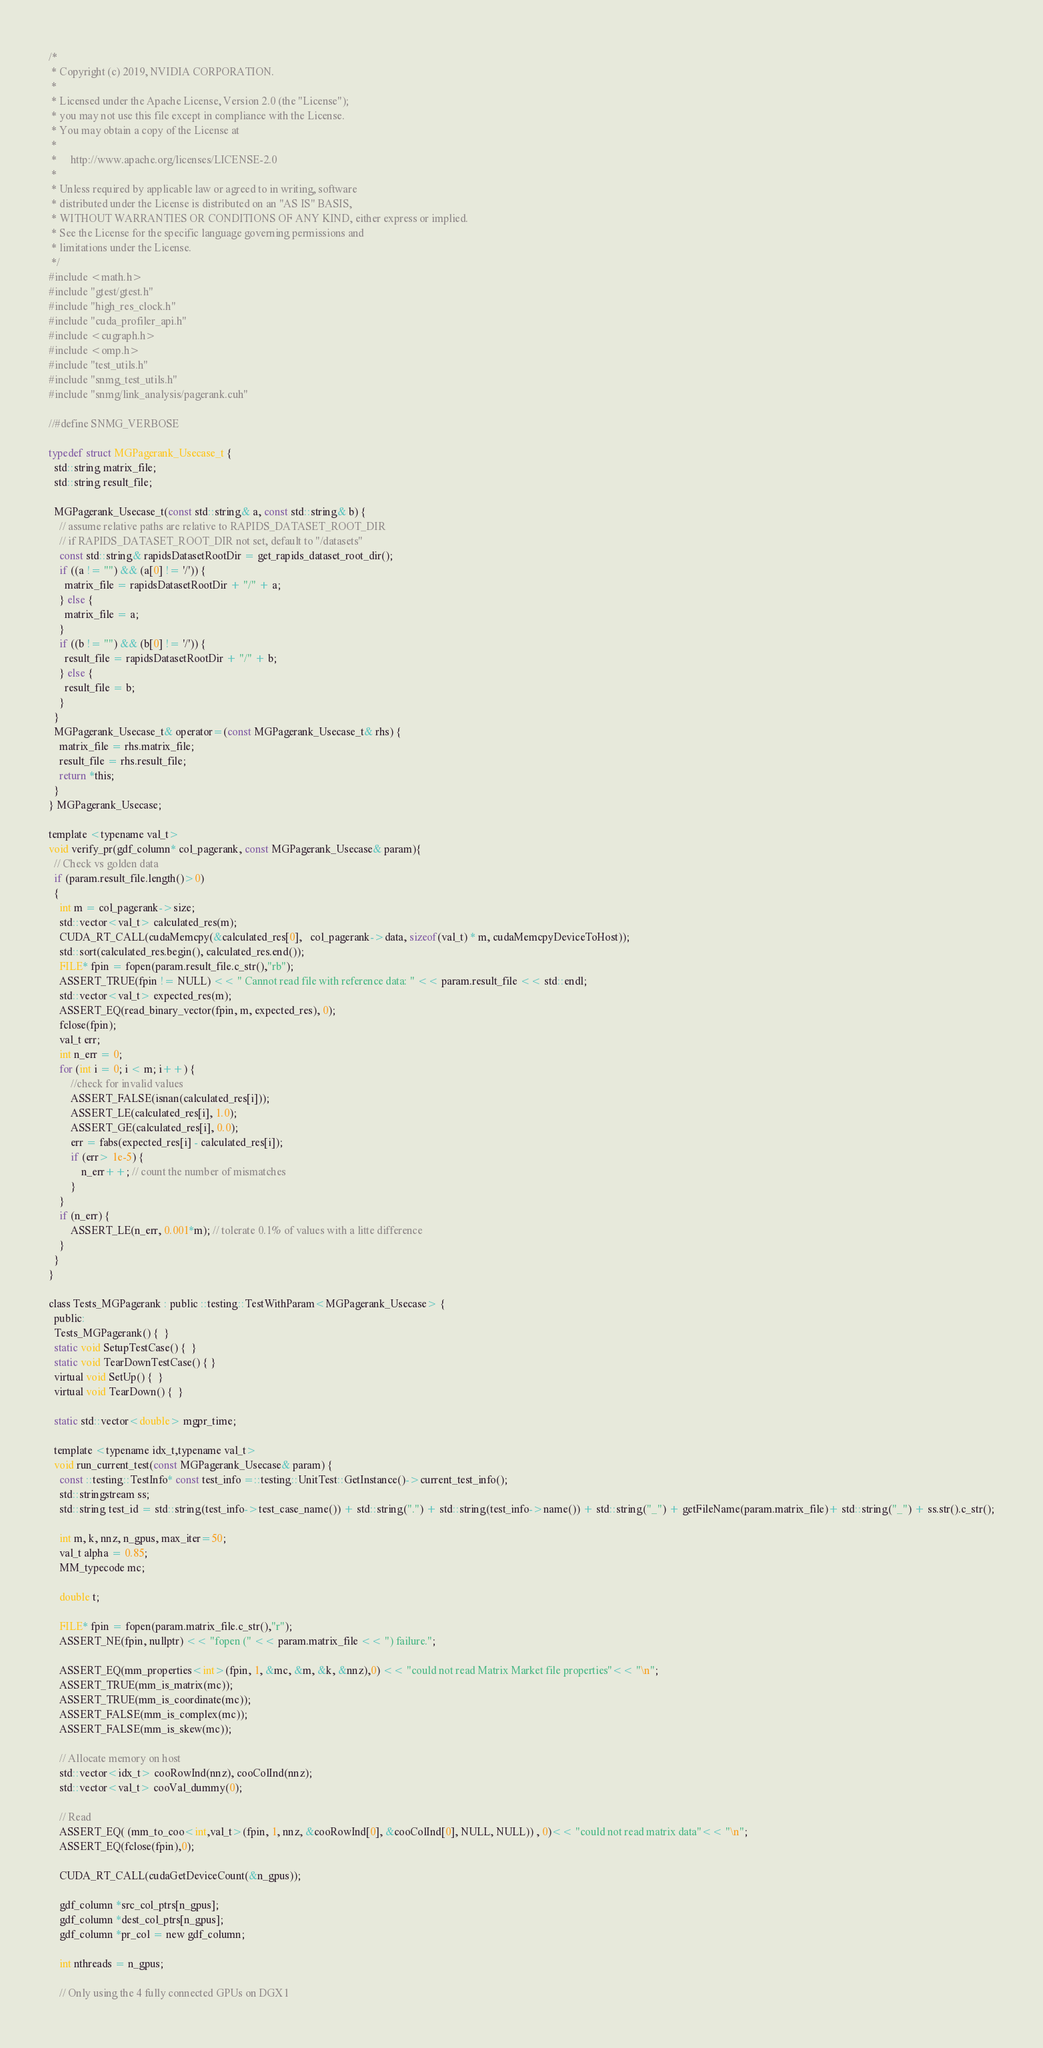<code> <loc_0><loc_0><loc_500><loc_500><_Cuda_>/*
 * Copyright (c) 2019, NVIDIA CORPORATION.
 *
 * Licensed under the Apache License, Version 2.0 (the "License");
 * you may not use this file except in compliance with the License.
 * You may obtain a copy of the License at
 *
 *     http://www.apache.org/licenses/LICENSE-2.0
 *
 * Unless required by applicable law or agreed to in writing, software
 * distributed under the License is distributed on an "AS IS" BASIS,
 * WITHOUT WARRANTIES OR CONDITIONS OF ANY KIND, either express or implied.
 * See the License for the specific language governing permissions and
 * limitations under the License.
 */
#include <math.h>
#include "gtest/gtest.h"
#include "high_res_clock.h"
#include "cuda_profiler_api.h"
#include <cugraph.h>
#include <omp.h>
#include "test_utils.h"
#include "snmg_test_utils.h"
#include "snmg/link_analysis/pagerank.cuh"

//#define SNMG_VERBOSE

typedef struct MGPagerank_Usecase_t {
  std::string matrix_file;
  std::string result_file;

  MGPagerank_Usecase_t(const std::string& a, const std::string& b) {
    // assume relative paths are relative to RAPIDS_DATASET_ROOT_DIR
    // if RAPIDS_DATASET_ROOT_DIR not set, default to "/datasets"
    const std::string& rapidsDatasetRootDir = get_rapids_dataset_root_dir();
    if ((a != "") && (a[0] != '/')) {
      matrix_file = rapidsDatasetRootDir + "/" + a;
    } else {
      matrix_file = a;
    }
    if ((b != "") && (b[0] != '/')) {
      result_file = rapidsDatasetRootDir + "/" + b;
    } else {
      result_file = b;
    }
  }
  MGPagerank_Usecase_t& operator=(const MGPagerank_Usecase_t& rhs) {
    matrix_file = rhs.matrix_file;
    result_file = rhs.result_file;
    return *this;
  }
} MGPagerank_Usecase;

template <typename val_t>
void verify_pr(gdf_column* col_pagerank, const MGPagerank_Usecase& param){
  // Check vs golden data
  if (param.result_file.length()>0)
  {
    int m = col_pagerank->size;
    std::vector<val_t> calculated_res(m);
    CUDA_RT_CALL(cudaMemcpy(&calculated_res[0],   col_pagerank->data, sizeof(val_t) * m, cudaMemcpyDeviceToHost));
    std::sort(calculated_res.begin(), calculated_res.end());
    FILE* fpin = fopen(param.result_file.c_str(),"rb");
    ASSERT_TRUE(fpin != NULL) << " Cannot read file with reference data: " << param.result_file << std::endl;
    std::vector<val_t> expected_res(m);
    ASSERT_EQ(read_binary_vector(fpin, m, expected_res), 0);
    fclose(fpin);
    val_t err;
    int n_err = 0;
    for (int i = 0; i < m; i++) {
        //check for invalid values
        ASSERT_FALSE(isnan(calculated_res[i])); 
        ASSERT_LE(calculated_res[i], 1.0);
        ASSERT_GE(calculated_res[i], 0.0);
        err = fabs(expected_res[i] - calculated_res[i]);
        if (err> 1e-5) {
            n_err++; // count the number of mismatches 
        }
    }
    if (n_err) {
        ASSERT_LE(n_err, 0.001*m); // tolerate 0.1% of values with a litte difference
    }
  }
}

class Tests_MGPagerank : public ::testing::TestWithParam<MGPagerank_Usecase> {
  public:
  Tests_MGPagerank() {  }
  static void SetupTestCase() {  }
  static void TearDownTestCase() { }
  virtual void SetUp() {  }
  virtual void TearDown() {  }

  static std::vector<double> mgpr_time;   
  
  template <typename idx_t,typename val_t>
  void run_current_test(const MGPagerank_Usecase& param) {
    const ::testing::TestInfo* const test_info =::testing::UnitTest::GetInstance()->current_test_info();
    std::stringstream ss; 
    std::string test_id = std::string(test_info->test_case_name()) + std::string(".") + std::string(test_info->name()) + std::string("_") + getFileName(param.matrix_file)+ std::string("_") + ss.str().c_str();

    int m, k, nnz, n_gpus, max_iter=50;
    val_t alpha = 0.85;
    MM_typecode mc;

    double t;

    FILE* fpin = fopen(param.matrix_file.c_str(),"r");
    ASSERT_NE(fpin, nullptr) << "fopen (" << param.matrix_file << ") failure.";

    ASSERT_EQ(mm_properties<int>(fpin, 1, &mc, &m, &k, &nnz),0) << "could not read Matrix Market file properties"<< "\n";
    ASSERT_TRUE(mm_is_matrix(mc));
    ASSERT_TRUE(mm_is_coordinate(mc));
    ASSERT_FALSE(mm_is_complex(mc));
    ASSERT_FALSE(mm_is_skew(mc));

    // Allocate memory on host
    std::vector<idx_t> cooRowInd(nnz), cooColInd(nnz);
    std::vector<val_t> cooVal_dummy(0);

    // Read
    ASSERT_EQ( (mm_to_coo<int,val_t>(fpin, 1, nnz, &cooRowInd[0], &cooColInd[0], NULL, NULL)) , 0)<< "could not read matrix data"<< "\n";
    ASSERT_EQ(fclose(fpin),0);

    CUDA_RT_CALL(cudaGetDeviceCount(&n_gpus));  

    gdf_column *src_col_ptrs[n_gpus];
    gdf_column *dest_col_ptrs[n_gpus];
    gdf_column *pr_col = new gdf_column;
    
    int nthreads = n_gpus;

    // Only using the 4 fully connected GPUs on DGX1</code> 